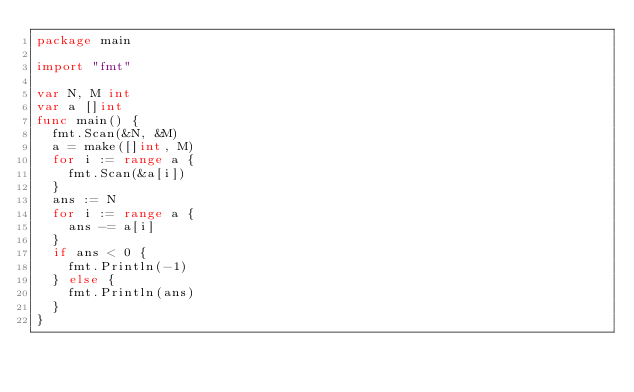Convert code to text. <code><loc_0><loc_0><loc_500><loc_500><_Go_>package main

import "fmt"

var N, M int
var a []int
func main() {
	fmt.Scan(&N, &M)
	a = make([]int, M)
	for i := range a {
		fmt.Scan(&a[i])
	}
	ans := N
	for i := range a {
		ans -= a[i]
	}
	if ans < 0 {
		fmt.Println(-1)
	} else {
		fmt.Println(ans)
	}
}
</code> 